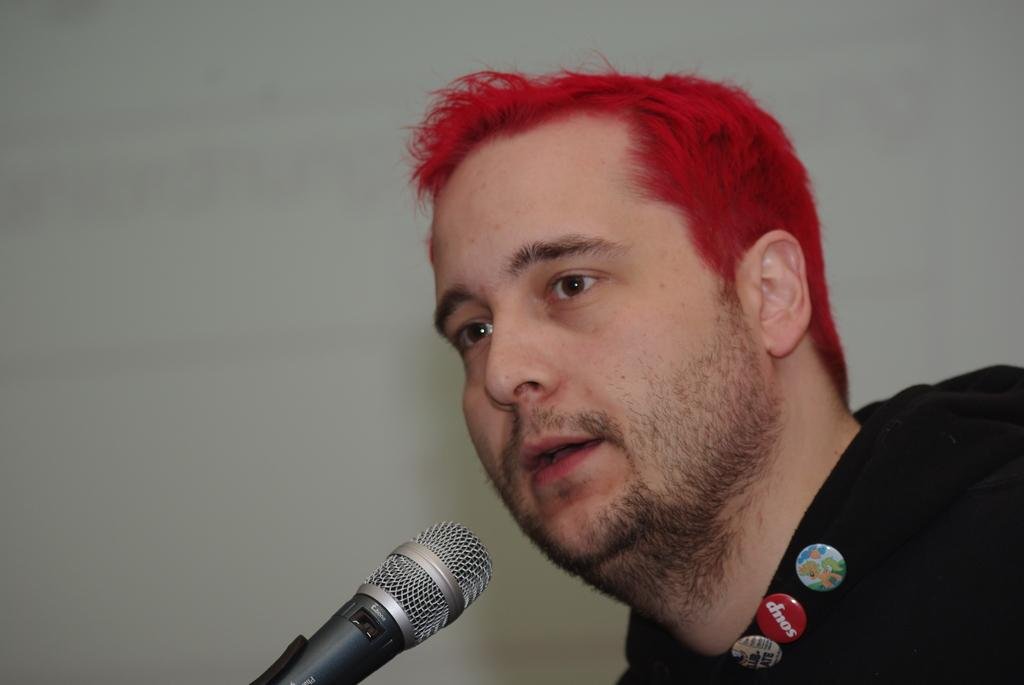Who or what is the main subject of the image? There is a person in the image. What is the person wearing? The person is wearing a black dress. Are there any notable details on the dress? Yes, there are three badges on the dress. What object is in front of the person? There is a microphone in front of the person. What color is the background of the image? The background of the image is white. What type of cabbage is being offered on the floor in the image? There is no cabbage present in the image, and no offer is being made on the floor. 